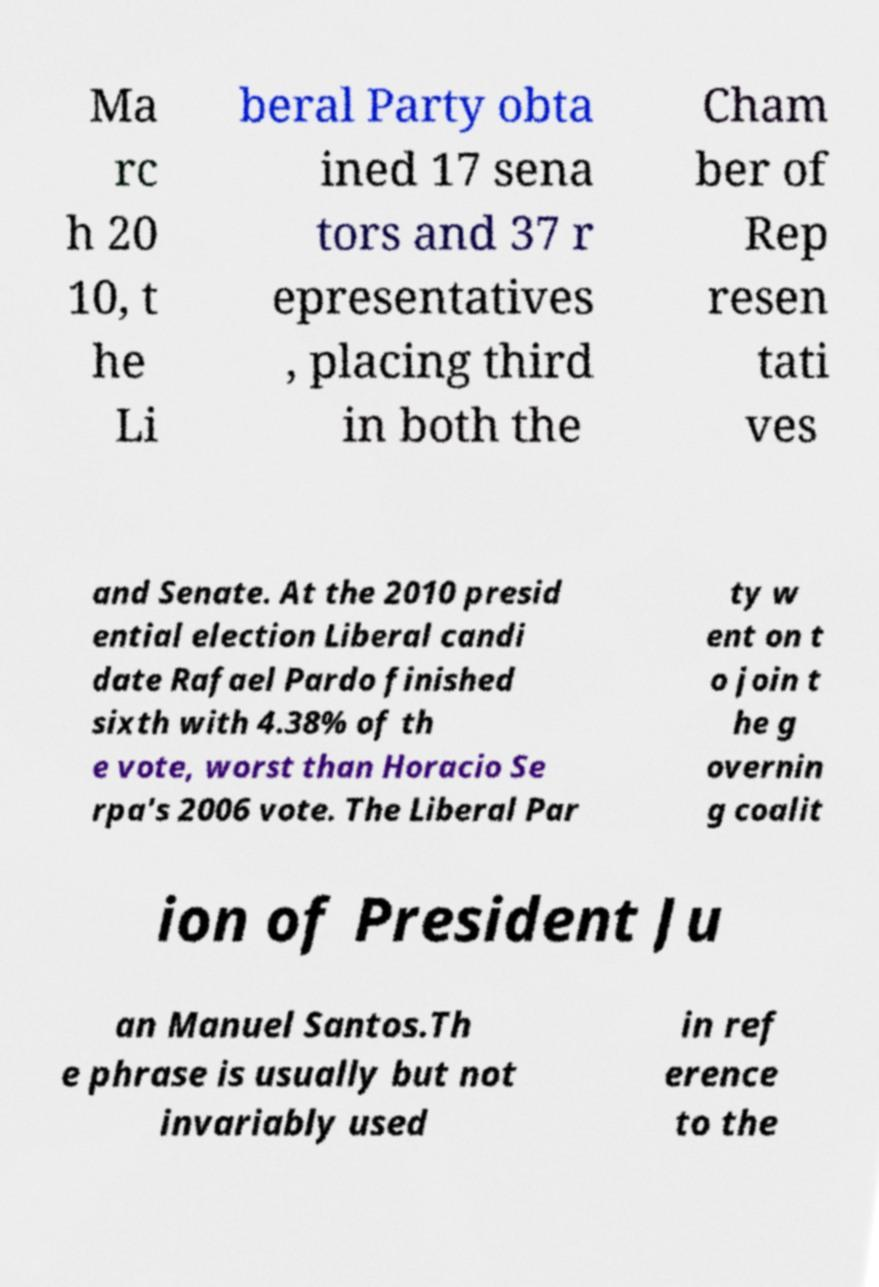What messages or text are displayed in this image? I need them in a readable, typed format. Ma rc h 20 10, t he Li beral Party obta ined 17 sena tors and 37 r epresentatives , placing third in both the Cham ber of Rep resen tati ves and Senate. At the 2010 presid ential election Liberal candi date Rafael Pardo finished sixth with 4.38% of th e vote, worst than Horacio Se rpa's 2006 vote. The Liberal Par ty w ent on t o join t he g overnin g coalit ion of President Ju an Manuel Santos.Th e phrase is usually but not invariably used in ref erence to the 